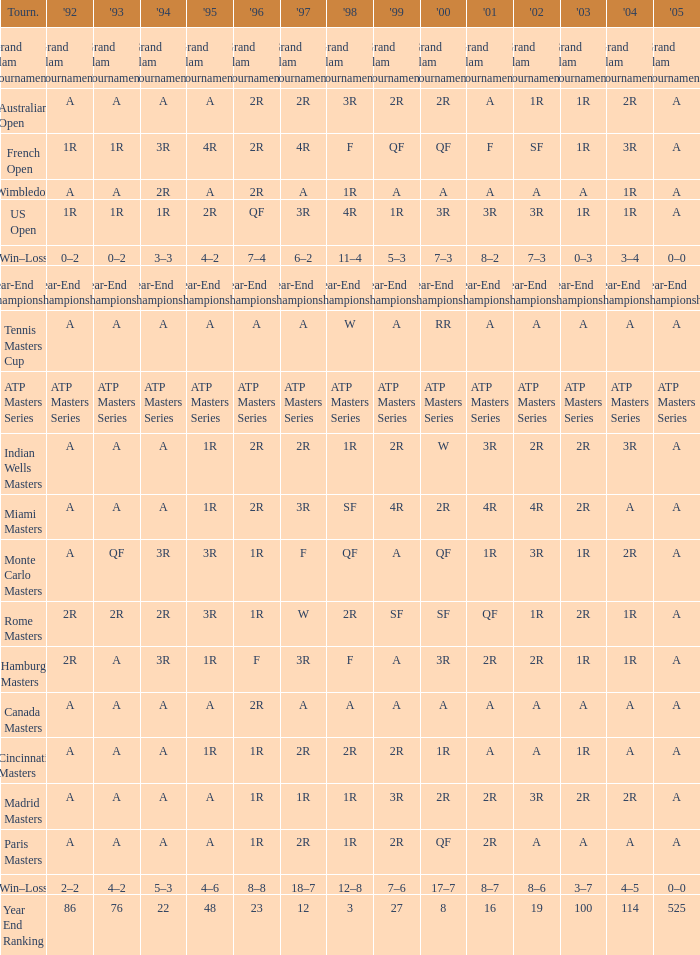What is 1998, when 1997 is "3R", and when 1992 is "A"? SF. 